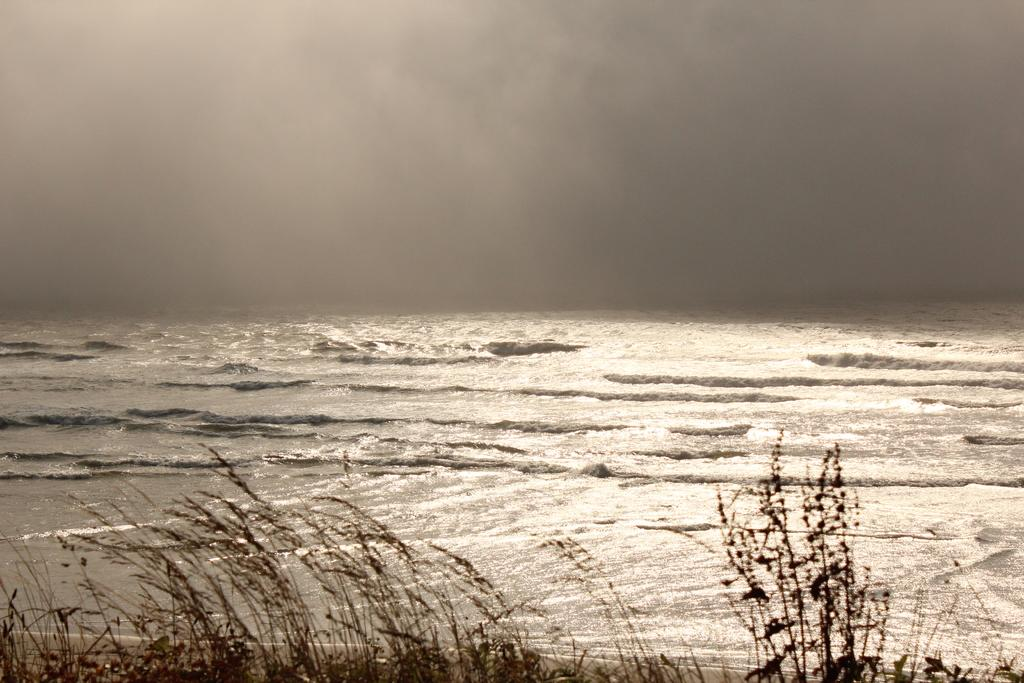What type of vegetation is present in the image? There is grass in the image. What natural element is visible besides the grass? There is water visible in the image. How would you describe the sky in the background? The sky in the background is cloudy. What type of rock formation can be seen in the image? There is no rock formation present in the image; it features grass, water, and a cloudy sky. What type of circle is visible in the image? There is no circle present in the image. 